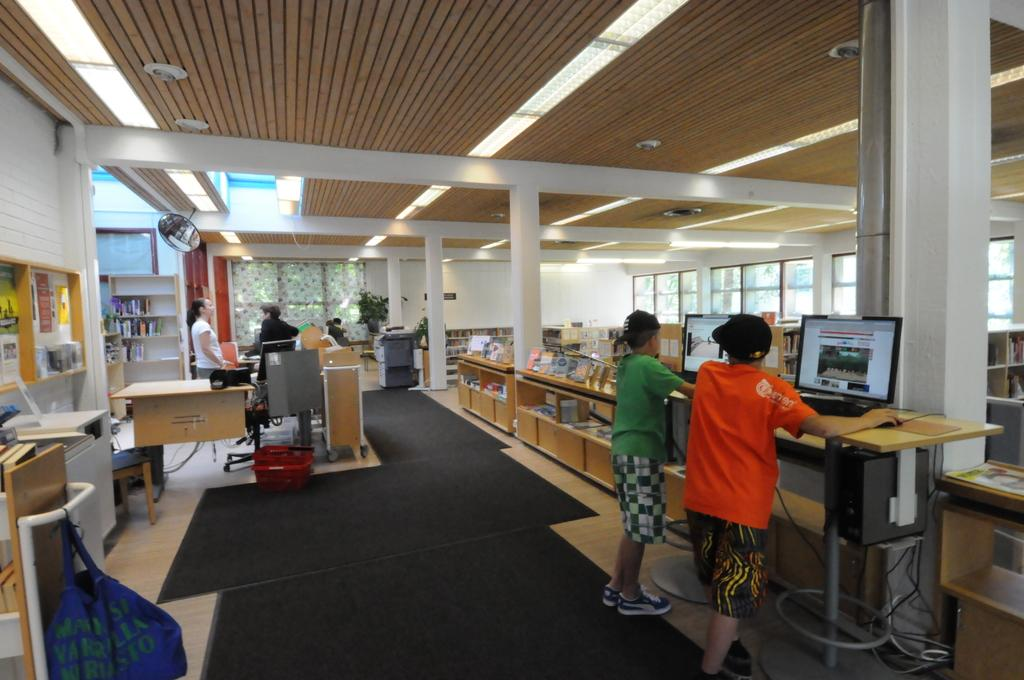Who is standing on the left side of the image? There is a woman standing on the left side of the image. What can be seen at the top of the image? There is a light at the top of the image. Who is standing on the right side of the image? There are two men standing on the right side of the image. What are the two men doing in the image? The two men are playing games on a system. What type of authority does the woman have in the image? There is no indication of the woman's authority in the image. What observation can be made about the middle of the image? There is no specific observation about the middle of the image, as the provided facts do not mention anything in the middle. 